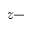Convert formula to latex. <formula><loc_0><loc_0><loc_500><loc_500>z -</formula> 